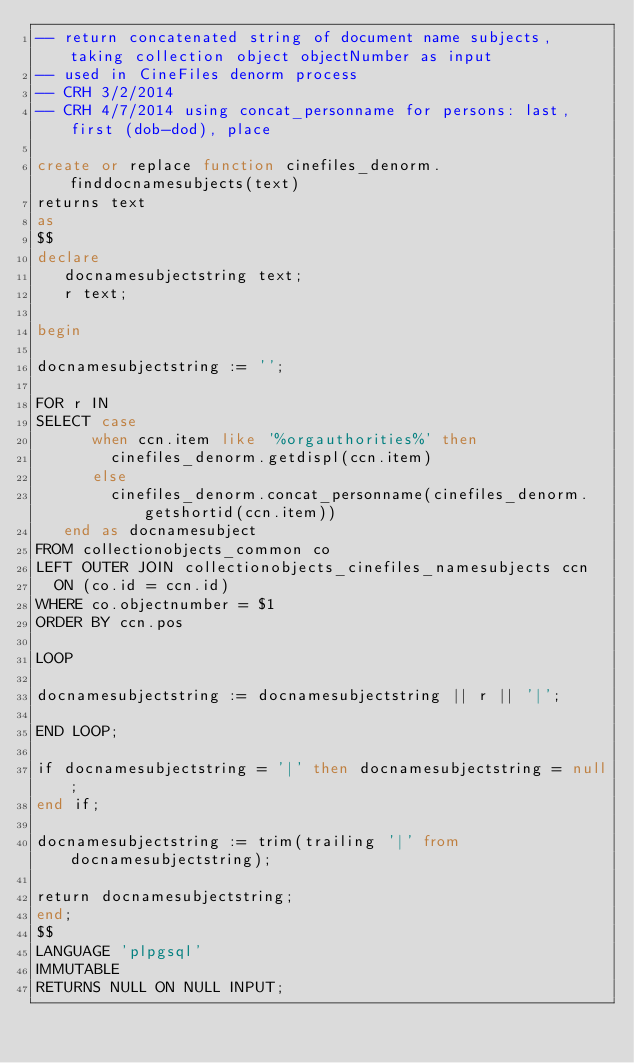<code> <loc_0><loc_0><loc_500><loc_500><_SQL_>-- return concatenated string of document name subjects, taking collection object objectNumber as input
-- used in CineFiles denorm process
-- CRH 3/2/2014
-- CRH 4/7/2014 using concat_personname for persons: last, first (dob-dod), place

create or replace function cinefiles_denorm.finddocnamesubjects(text)
returns text
as
$$
declare
   docnamesubjectstring text;
   r text;

begin

docnamesubjectstring := '';

FOR r IN
SELECT case 
      when ccn.item like '%orgauthorities%' then
        cinefiles_denorm.getdispl(ccn.item)       
      else
        cinefiles_denorm.concat_personname(cinefiles_denorm.getshortid(ccn.item))     
   end as docnamesubject
FROM collectionobjects_common co
LEFT OUTER JOIN collectionobjects_cinefiles_namesubjects ccn
  ON (co.id = ccn.id)
WHERE co.objectnumber = $1
ORDER BY ccn.pos

LOOP

docnamesubjectstring := docnamesubjectstring || r || '|';

END LOOP;

if docnamesubjectstring = '|' then docnamesubjectstring = null;
end if;

docnamesubjectstring := trim(trailing '|' from docnamesubjectstring);

return docnamesubjectstring;
end;
$$
LANGUAGE 'plpgsql'
IMMUTABLE
RETURNS NULL ON NULL INPUT;</code> 